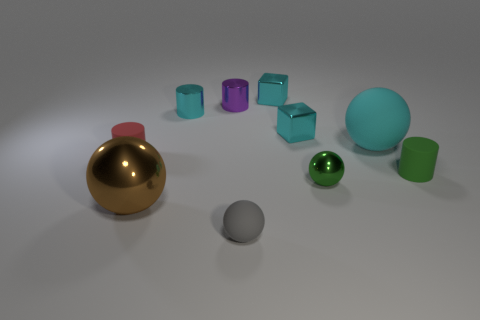Subtract all spheres. How many objects are left? 6 Subtract 0 purple spheres. How many objects are left? 10 Subtract all small green metallic spheres. Subtract all tiny rubber balls. How many objects are left? 8 Add 8 gray objects. How many gray objects are left? 9 Add 5 small gray objects. How many small gray objects exist? 6 